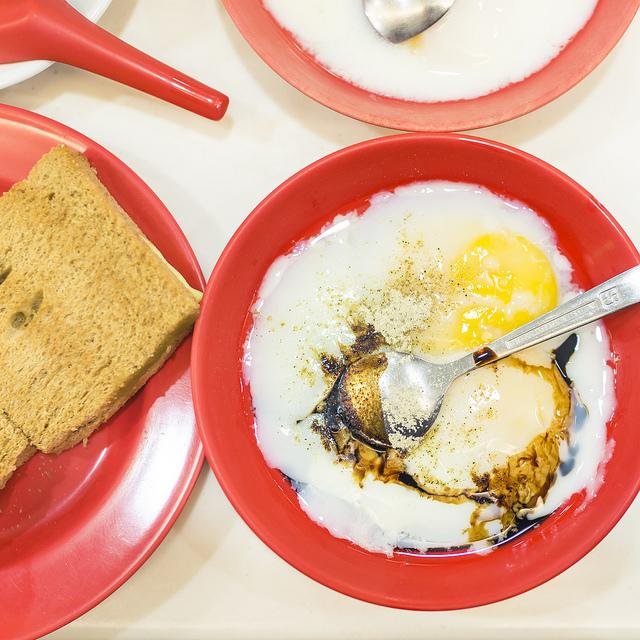Which food offers the most protein? Please explain your reasoning. egg. It has more protein than almost everything other than meat. 